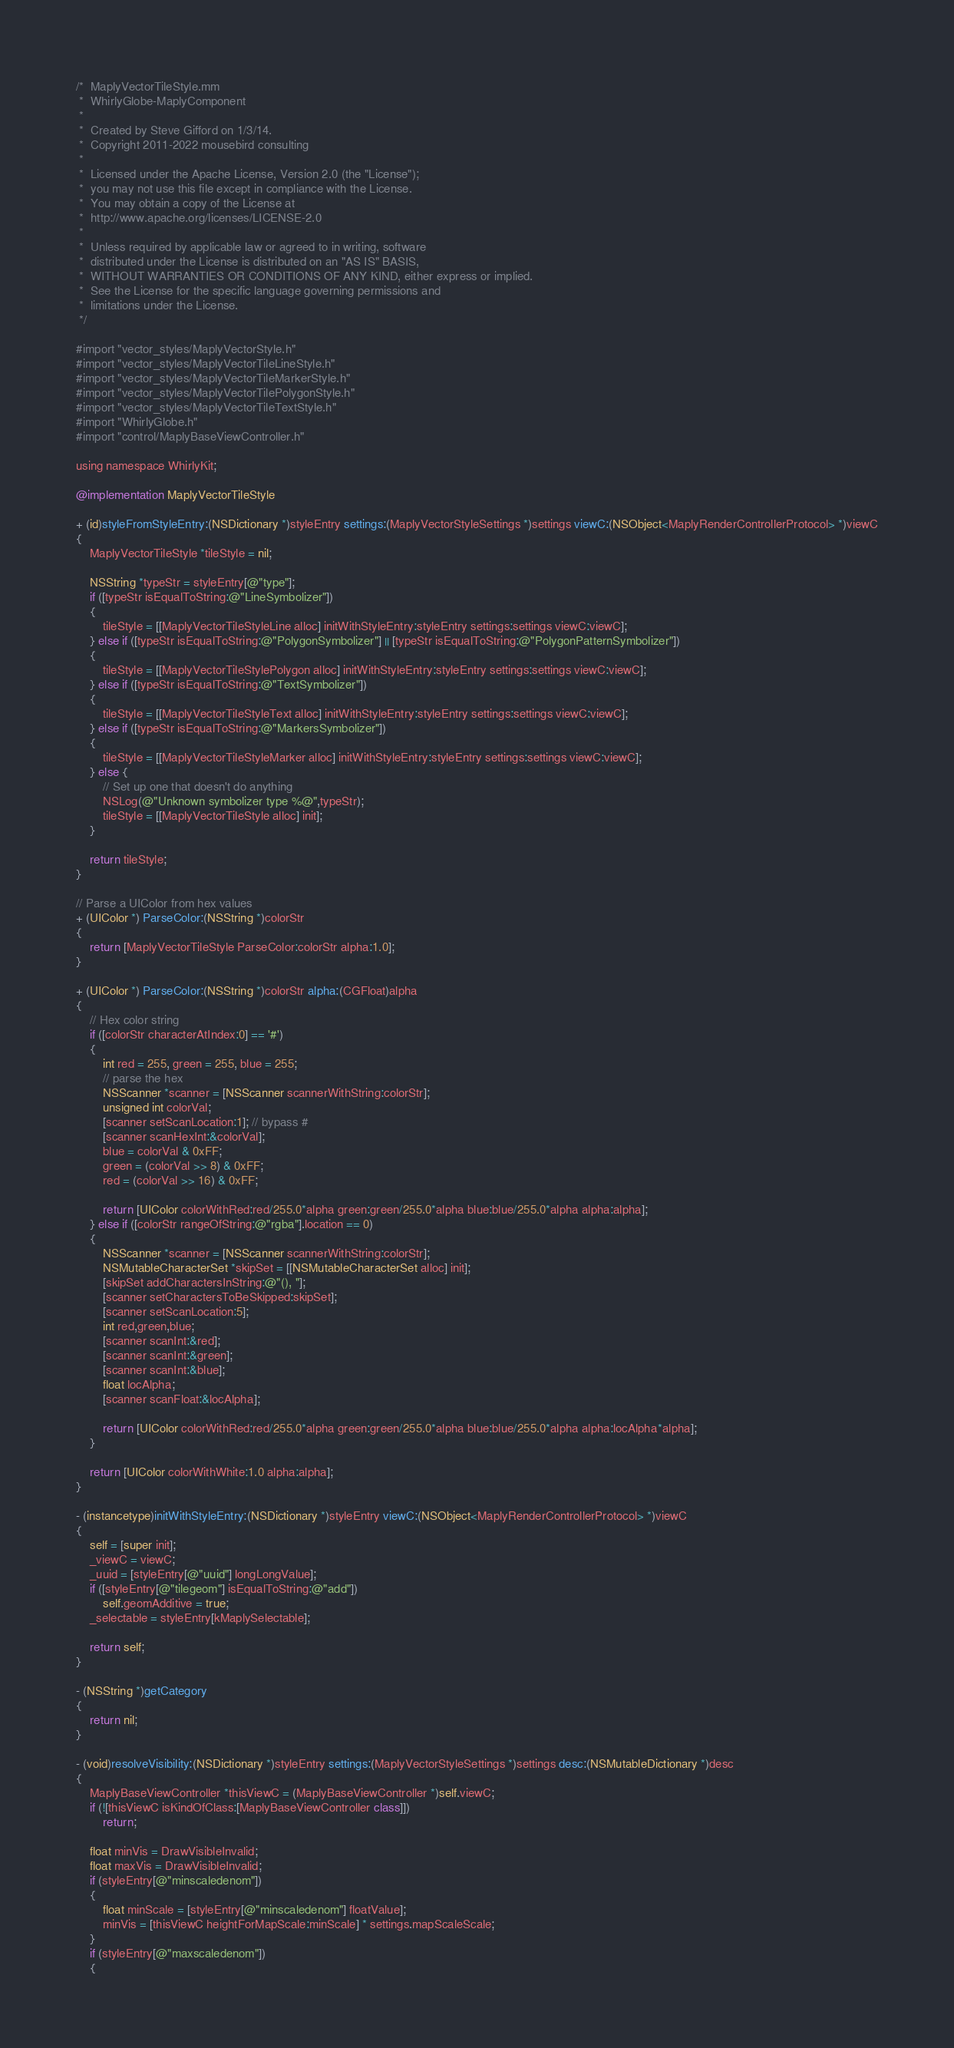<code> <loc_0><loc_0><loc_500><loc_500><_ObjectiveC_>/*  MaplyVectorTileStyle.mm
 *  WhirlyGlobe-MaplyComponent
 *
 *  Created by Steve Gifford on 1/3/14.
 *  Copyright 2011-2022 mousebird consulting
 *
 *  Licensed under the Apache License, Version 2.0 (the "License");
 *  you may not use this file except in compliance with the License.
 *  You may obtain a copy of the License at
 *  http://www.apache.org/licenses/LICENSE-2.0
 *
 *  Unless required by applicable law or agreed to in writing, software
 *  distributed under the License is distributed on an "AS IS" BASIS,
 *  WITHOUT WARRANTIES OR CONDITIONS OF ANY KIND, either express or implied.
 *  See the License for the specific language governing permissions and
 *  limitations under the License.
 */

#import "vector_styles/MaplyVectorStyle.h"
#import "vector_styles/MaplyVectorTileLineStyle.h"
#import "vector_styles/MaplyVectorTileMarkerStyle.h"
#import "vector_styles/MaplyVectorTilePolygonStyle.h"
#import "vector_styles/MaplyVectorTileTextStyle.h"
#import "WhirlyGlobe.h"
#import "control/MaplyBaseViewController.h"

using namespace WhirlyKit;

@implementation MaplyVectorTileStyle

+ (id)styleFromStyleEntry:(NSDictionary *)styleEntry settings:(MaplyVectorStyleSettings *)settings viewC:(NSObject<MaplyRenderControllerProtocol> *)viewC
{
    MaplyVectorTileStyle *tileStyle = nil;
    
    NSString *typeStr = styleEntry[@"type"];
    if ([typeStr isEqualToString:@"LineSymbolizer"])
    {
        tileStyle = [[MaplyVectorTileStyleLine alloc] initWithStyleEntry:styleEntry settings:settings viewC:viewC];
    } else if ([typeStr isEqualToString:@"PolygonSymbolizer"] || [typeStr isEqualToString:@"PolygonPatternSymbolizer"])
    {
        tileStyle = [[MaplyVectorTileStylePolygon alloc] initWithStyleEntry:styleEntry settings:settings viewC:viewC];
    } else if ([typeStr isEqualToString:@"TextSymbolizer"])
    {
        tileStyle = [[MaplyVectorTileStyleText alloc] initWithStyleEntry:styleEntry settings:settings viewC:viewC];
    } else if ([typeStr isEqualToString:@"MarkersSymbolizer"])
    {
        tileStyle = [[MaplyVectorTileStyleMarker alloc] initWithStyleEntry:styleEntry settings:settings viewC:viewC];
    } else {
        // Set up one that doesn't do anything
        NSLog(@"Unknown symbolizer type %@",typeStr);
        tileStyle = [[MaplyVectorTileStyle alloc] init];
    }
    
    return tileStyle;
}

// Parse a UIColor from hex values
+ (UIColor *) ParseColor:(NSString *)colorStr
{
    return [MaplyVectorTileStyle ParseColor:colorStr alpha:1.0];
}

+ (UIColor *) ParseColor:(NSString *)colorStr alpha:(CGFloat)alpha
{
    // Hex color string
    if ([colorStr characterAtIndex:0] == '#')
    {
        int red = 255, green = 255, blue = 255;
        // parse the hex
        NSScanner *scanner = [NSScanner scannerWithString:colorStr];
        unsigned int colorVal;
        [scanner setScanLocation:1]; // bypass #
        [scanner scanHexInt:&colorVal];
        blue = colorVal & 0xFF;
        green = (colorVal >> 8) & 0xFF;
        red = (colorVal >> 16) & 0xFF;
        
        return [UIColor colorWithRed:red/255.0*alpha green:green/255.0*alpha blue:blue/255.0*alpha alpha:alpha];
    } else if ([colorStr rangeOfString:@"rgba"].location == 0)
    {
        NSScanner *scanner = [NSScanner scannerWithString:colorStr];
        NSMutableCharacterSet *skipSet = [[NSMutableCharacterSet alloc] init];
        [skipSet addCharactersInString:@"(), "];
        [scanner setCharactersToBeSkipped:skipSet];
        [scanner setScanLocation:5];
        int red,green,blue;
        [scanner scanInt:&red];
        [scanner scanInt:&green];
        [scanner scanInt:&blue];
        float locAlpha;
        [scanner scanFloat:&locAlpha];
        
        return [UIColor colorWithRed:red/255.0*alpha green:green/255.0*alpha blue:blue/255.0*alpha alpha:locAlpha*alpha];
    }
    
    return [UIColor colorWithWhite:1.0 alpha:alpha];
}

- (instancetype)initWithStyleEntry:(NSDictionary *)styleEntry viewC:(NSObject<MaplyRenderControllerProtocol> *)viewC
{
    self = [super init];
    _viewC = viewC;
    _uuid = [styleEntry[@"uuid"] longLongValue];
    if ([styleEntry[@"tilegeom"] isEqualToString:@"add"])
        self.geomAdditive = true;
    _selectable = styleEntry[kMaplySelectable];
    
    return self;
}

- (NSString *)getCategory
{
    return nil;
}

- (void)resolveVisibility:(NSDictionary *)styleEntry settings:(MaplyVectorStyleSettings *)settings desc:(NSMutableDictionary *)desc
{
    MaplyBaseViewController *thisViewC = (MaplyBaseViewController *)self.viewC;
    if (![thisViewC isKindOfClass:[MaplyBaseViewController class]])
        return;
    
    float minVis = DrawVisibleInvalid;
    float maxVis = DrawVisibleInvalid;
    if (styleEntry[@"minscaledenom"])
    {
        float minScale = [styleEntry[@"minscaledenom"] floatValue];
        minVis = [thisViewC heightForMapScale:minScale] * settings.mapScaleScale;
    }
    if (styleEntry[@"maxscaledenom"])
    {</code> 